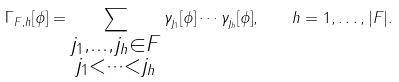Convert formula to latex. <formula><loc_0><loc_0><loc_500><loc_500>\Gamma _ { F , h } [ \phi ] = \sum _ { \substack { j _ { 1 } , \dots , j _ { h } \in F \\ j _ { 1 } < \dots < j _ { h } } } \gamma _ { j _ { 1 } } [ \phi ] \cdots \gamma _ { j _ { h } } [ \phi ] , \quad h = 1 , \dots , | F | .</formula> 